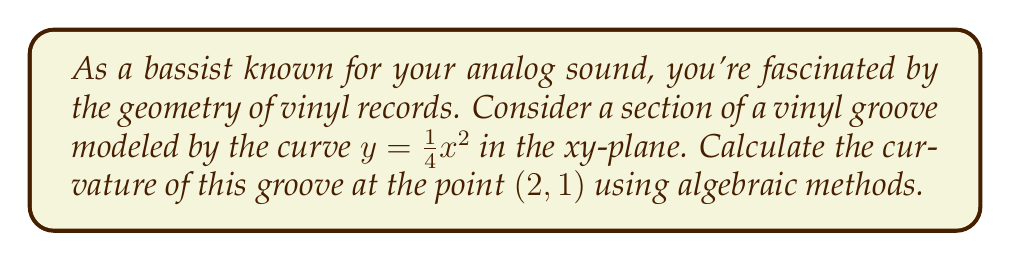Show me your answer to this math problem. Let's approach this step-by-step:

1) The curvature $\kappa$ of a curve $y = f(x)$ at a point $(x, y)$ is given by the formula:

   $$\kappa = \frac{|f''(x)|}{(1 + [f'(x)]^2)^{3/2}}$$

2) For our curve $y = \frac{1}{4}x^2$, we need to find $f'(x)$ and $f''(x)$:

   $f'(x) = \frac{1}{2}x$
   $f''(x) = \frac{1}{2}$

3) At the point $(2, 1)$, we have $x = 2$. Let's substitute this into $f'(x)$:

   $f'(2) = \frac{1}{2}(2) = 1$

4) Now we can substitute these values into our curvature formula:

   $$\kappa = \frac{|\frac{1}{2}|}{(1 + [1]^2)^{3/2}}$$

5) Simplify:

   $$\kappa = \frac{0.5}{(1 + 1)^{3/2}} = \frac{0.5}{2^{3/2}} = \frac{0.5}{2\sqrt{2}}$$

6) This can be further simplified:

   $$\kappa = \frac{1}{4\sqrt{2}}$$

This represents the curvature of the vinyl groove at the point (2, 1).
Answer: $\frac{1}{4\sqrt{2}}$ 